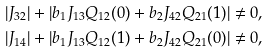Convert formula to latex. <formula><loc_0><loc_0><loc_500><loc_500>\left | J _ { 3 2 } \right | + \left | b _ { 1 } J _ { 1 3 } Q _ { 1 2 } ( 0 ) + b _ { 2 } J _ { 4 2 } Q _ { 2 1 } ( 1 ) \right | \ne 0 , \\ \left | J _ { 1 4 } \right | + \left | b _ { 1 } J _ { 1 3 } Q _ { 1 2 } ( 1 ) + b _ { 2 } J _ { 4 2 } Q _ { 2 1 } ( 0 ) \right | \ne 0 ,</formula> 